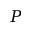<formula> <loc_0><loc_0><loc_500><loc_500>P</formula> 